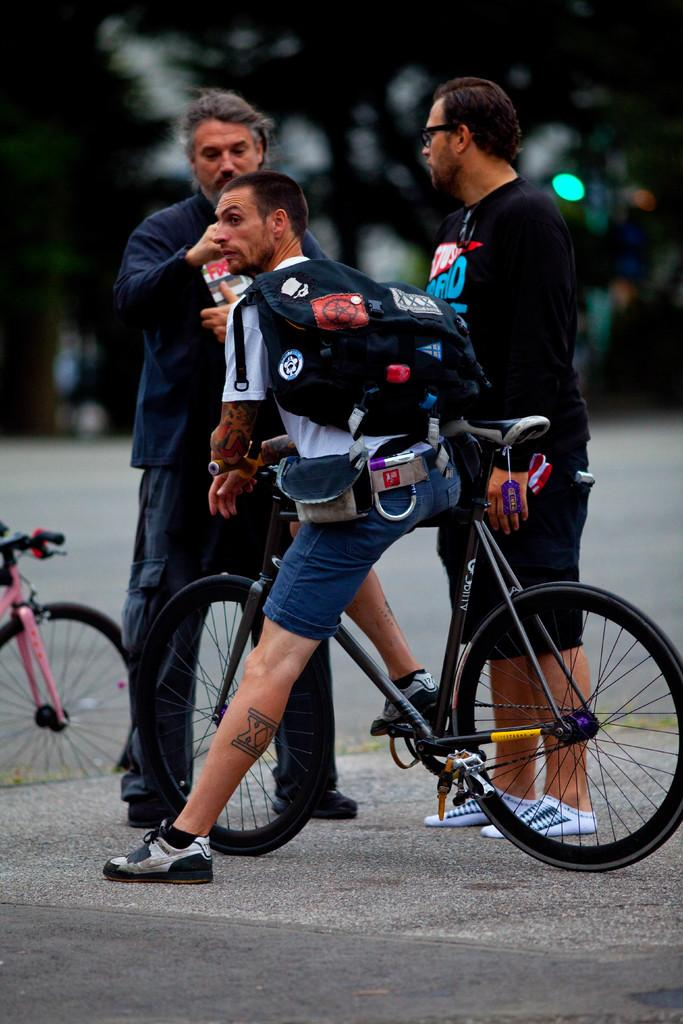How many people are in the image? There are three people in the image. What are the positions of the people in the image? Two of the people are standing, and one person is sitting on a bicycle. What is the person sitting on the bicycle wearing? The person sitting on the bicycle is wearing a backpack. What type of attack is being carried out by the frog in the image? There is no frog present in the image, so no attack can be observed. How many beds are visible in the image? There are no beds visible in the image. 